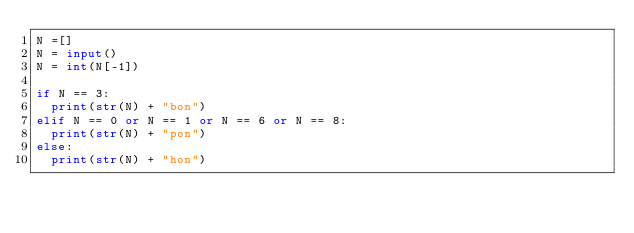<code> <loc_0><loc_0><loc_500><loc_500><_Python_>N =[]
N = input()
N = int(N[-1])

if N == 3:
  print(str(N) + "bon")
elif N == 0 or N == 1 or N == 6 or N == 8:
  print(str(N) + "pon")
else:
  print(str(N) + "hon")</code> 